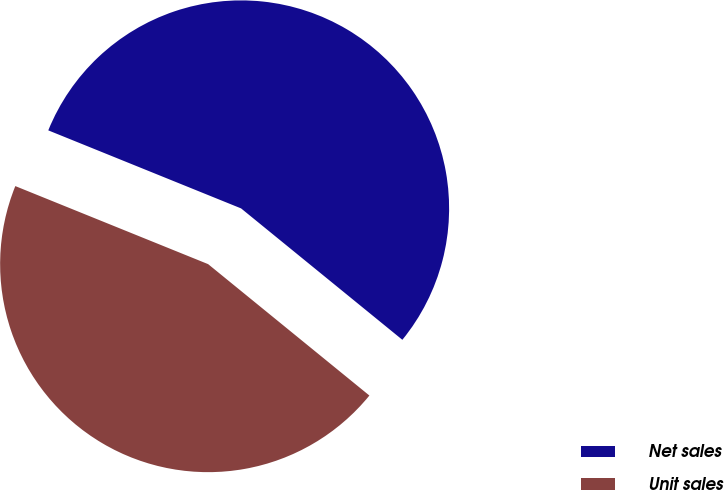Convert chart. <chart><loc_0><loc_0><loc_500><loc_500><pie_chart><fcel>Net sales<fcel>Unit sales<nl><fcel>54.76%<fcel>45.24%<nl></chart> 